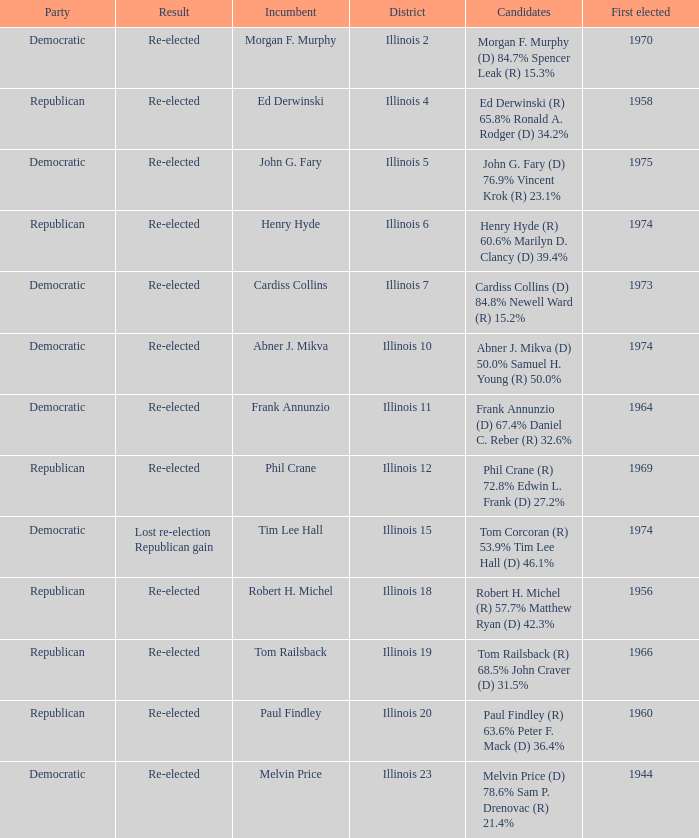Name the candidates for illinois 15 Tom Corcoran (R) 53.9% Tim Lee Hall (D) 46.1%. 